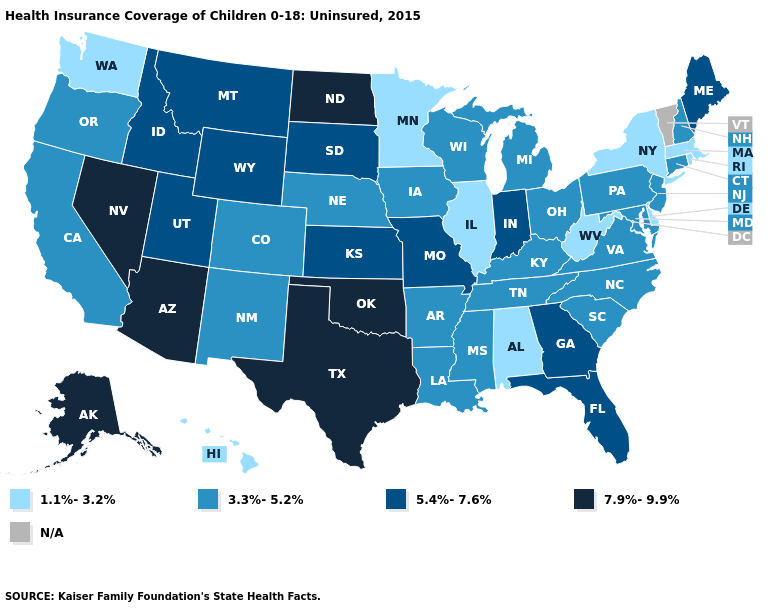Among the states that border New Jersey , does Pennsylvania have the lowest value?
Write a very short answer. No. What is the value of South Carolina?
Be succinct. 3.3%-5.2%. Which states hav the highest value in the Northeast?
Concise answer only. Maine. Among the states that border Georgia , does North Carolina have the lowest value?
Concise answer only. No. What is the lowest value in the West?
Short answer required. 1.1%-3.2%. Which states have the highest value in the USA?
Keep it brief. Alaska, Arizona, Nevada, North Dakota, Oklahoma, Texas. What is the value of Arkansas?
Concise answer only. 3.3%-5.2%. Name the states that have a value in the range 3.3%-5.2%?
Concise answer only. Arkansas, California, Colorado, Connecticut, Iowa, Kentucky, Louisiana, Maryland, Michigan, Mississippi, Nebraska, New Hampshire, New Jersey, New Mexico, North Carolina, Ohio, Oregon, Pennsylvania, South Carolina, Tennessee, Virginia, Wisconsin. Name the states that have a value in the range 7.9%-9.9%?
Answer briefly. Alaska, Arizona, Nevada, North Dakota, Oklahoma, Texas. How many symbols are there in the legend?
Short answer required. 5. What is the value of Oregon?
Write a very short answer. 3.3%-5.2%. Name the states that have a value in the range 1.1%-3.2%?
Quick response, please. Alabama, Delaware, Hawaii, Illinois, Massachusetts, Minnesota, New York, Rhode Island, Washington, West Virginia. Is the legend a continuous bar?
Be succinct. No. Name the states that have a value in the range N/A?
Write a very short answer. Vermont. Does Hawaii have the lowest value in the USA?
Quick response, please. Yes. 